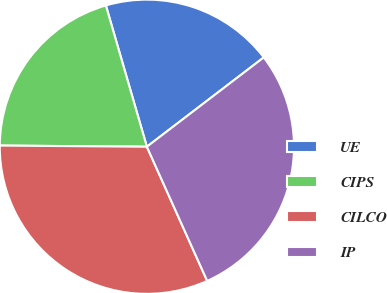Convert chart to OTSL. <chart><loc_0><loc_0><loc_500><loc_500><pie_chart><fcel>UE<fcel>CIPS<fcel>CILCO<fcel>IP<nl><fcel>19.11%<fcel>20.38%<fcel>31.85%<fcel>28.66%<nl></chart> 